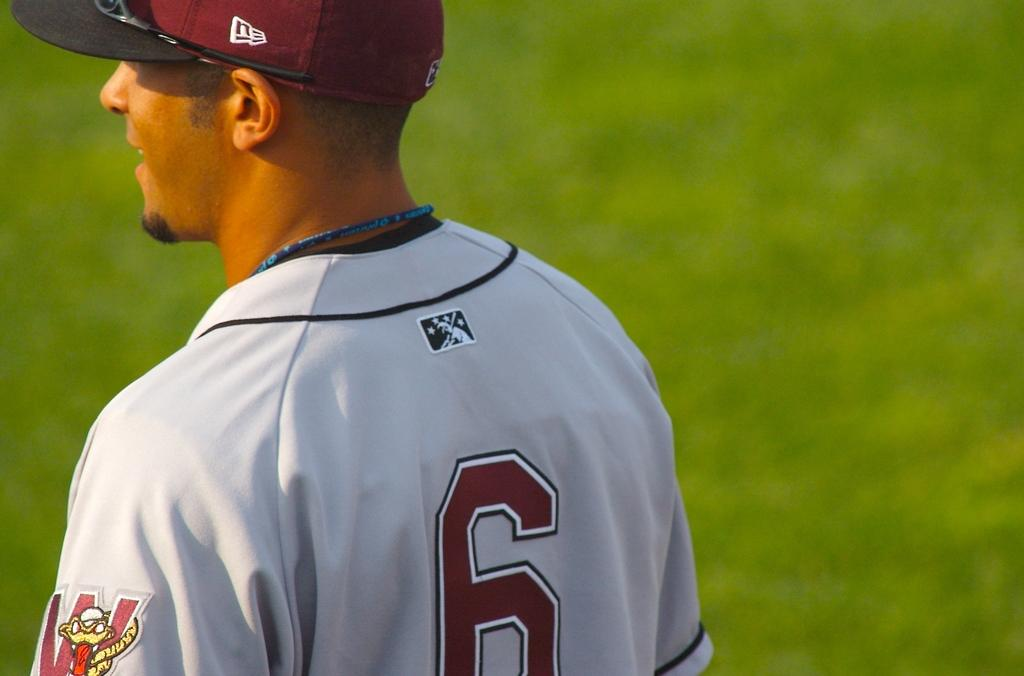<image>
Describe the image concisely. Player 6 is standing on the field and looking to the left. 